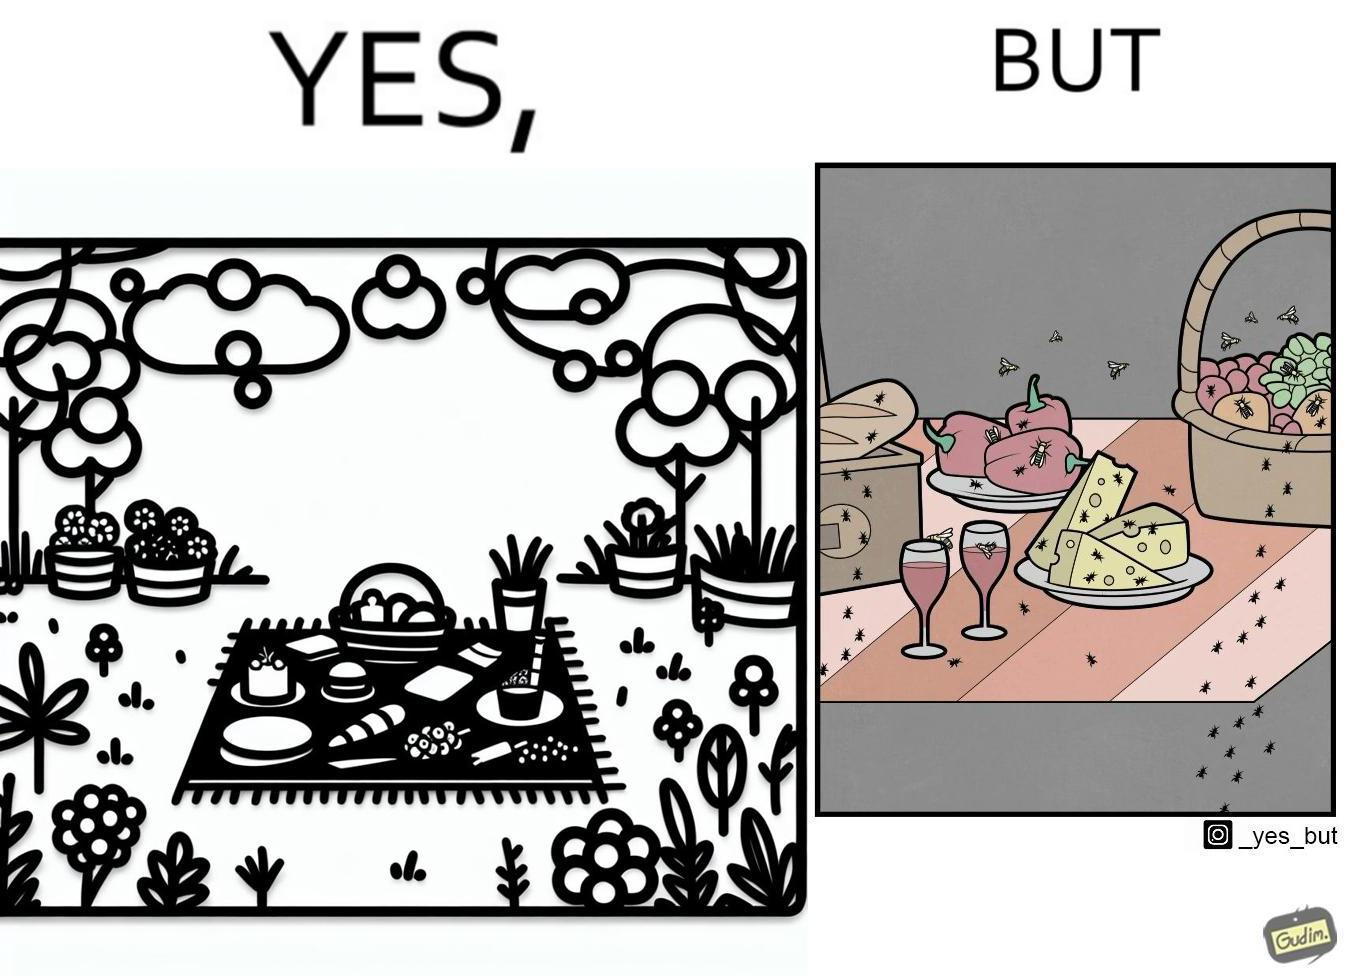Is this a satirical image? Yes, this image is satirical. 